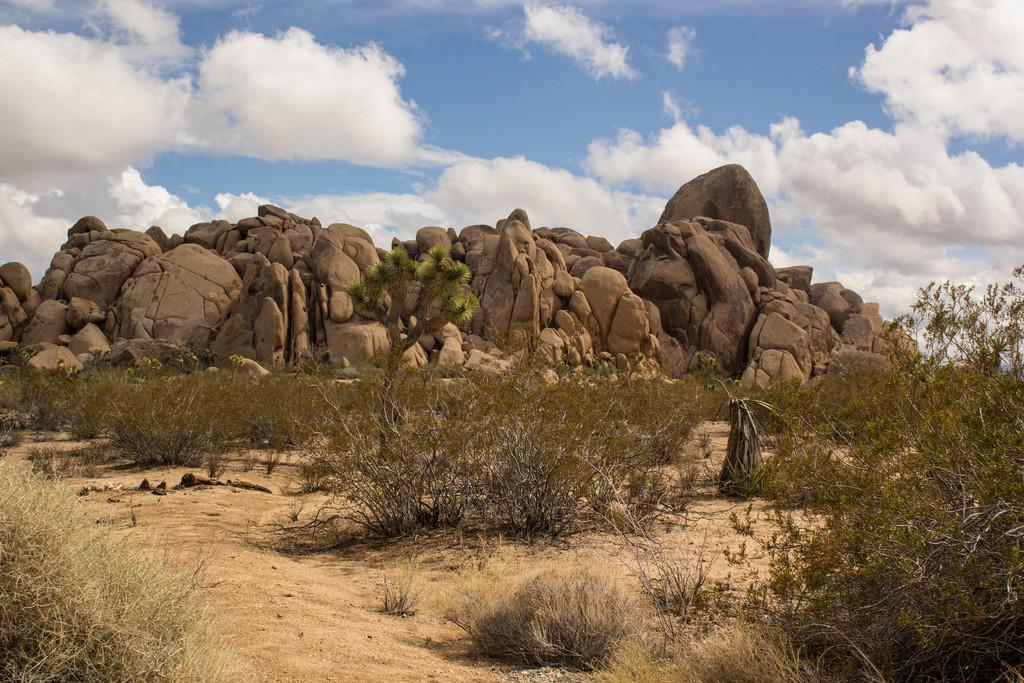What type of vegetation can be seen in the image? There are plants and trees in the image. What other natural elements are present in the image? There are rocks in the image. What is visible in the background of the image? The sky is visible in the background of the image. What can be seen in the sky? Clouds are present in the sky. How many chickens are sitting on the bed in the image? There is no bed or chickens present in the image. 